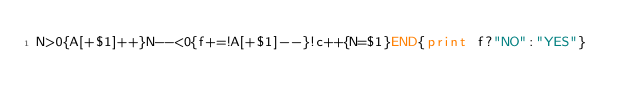Convert code to text. <code><loc_0><loc_0><loc_500><loc_500><_Awk_>N>0{A[+$1]++}N--<0{f+=!A[+$1]--}!c++{N=$1}END{print f?"NO":"YES"}</code> 